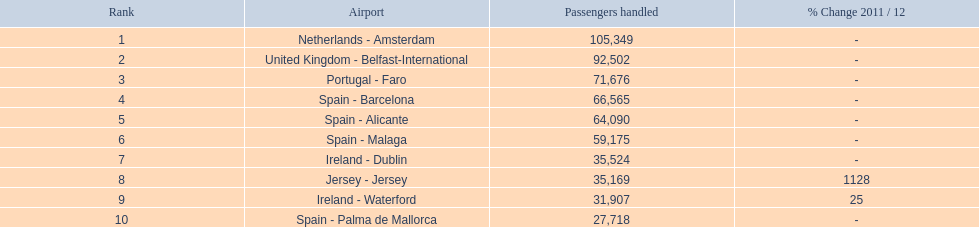What are the various airports worldwide? Netherlands - Amsterdam, United Kingdom - Belfast-International, Portugal - Faro, Spain - Barcelona, Spain - Alicante, Spain - Malaga, Ireland - Dublin, Jersey - Jersey, Ireland - Waterford, Spain - Palma de Mallorca. What is the cumulative passenger count they have dealt with? 105,349, 92,502, 71,676, 66,565, 64,090, 59,175, 35,524, 35,169, 31,907, 27,718. And which particular airport has had the most passengers? Netherlands - Amsterdam. 